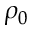<formula> <loc_0><loc_0><loc_500><loc_500>\rho _ { 0 }</formula> 